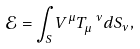Convert formula to latex. <formula><loc_0><loc_0><loc_500><loc_500>\mathcal { E } = \int _ { S } V ^ { \mu } T _ { \mu } ^ { \ \nu } d S _ { \nu } ,</formula> 